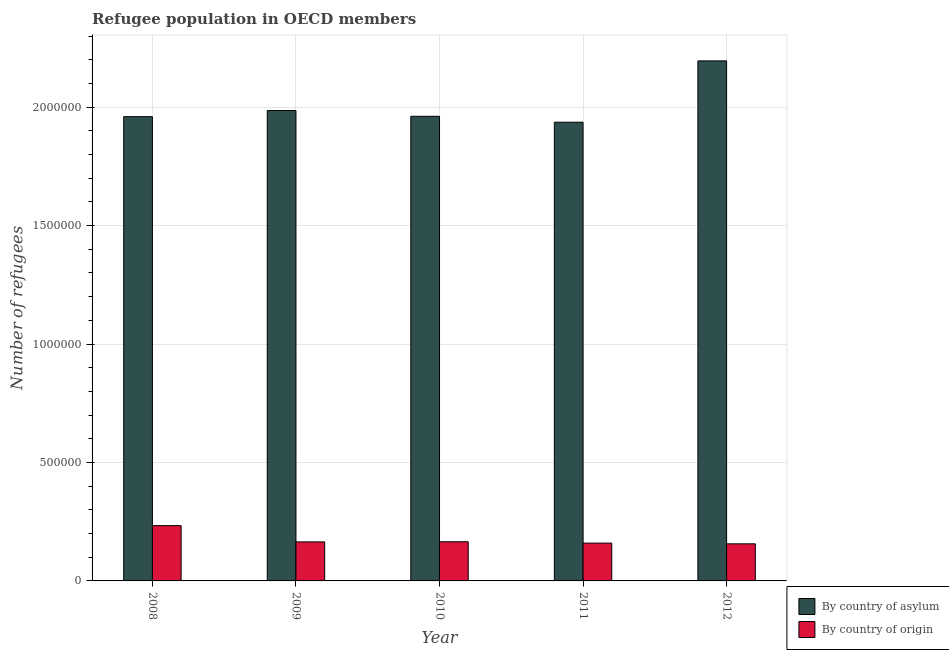Are the number of bars per tick equal to the number of legend labels?
Give a very brief answer. Yes. Are the number of bars on each tick of the X-axis equal?
Make the answer very short. Yes. In how many cases, is the number of bars for a given year not equal to the number of legend labels?
Provide a succinct answer. 0. What is the number of refugees by country of asylum in 2009?
Give a very brief answer. 1.99e+06. Across all years, what is the maximum number of refugees by country of asylum?
Provide a succinct answer. 2.20e+06. Across all years, what is the minimum number of refugees by country of origin?
Offer a very short reply. 1.57e+05. In which year was the number of refugees by country of origin maximum?
Provide a short and direct response. 2008. What is the total number of refugees by country of origin in the graph?
Your answer should be compact. 8.80e+05. What is the difference between the number of refugees by country of asylum in 2010 and that in 2012?
Your answer should be compact. -2.34e+05. What is the difference between the number of refugees by country of asylum in 2011 and the number of refugees by country of origin in 2008?
Give a very brief answer. -2.34e+04. What is the average number of refugees by country of asylum per year?
Your answer should be very brief. 2.01e+06. In how many years, is the number of refugees by country of origin greater than 800000?
Give a very brief answer. 0. What is the ratio of the number of refugees by country of asylum in 2011 to that in 2012?
Provide a succinct answer. 0.88. Is the number of refugees by country of asylum in 2008 less than that in 2009?
Ensure brevity in your answer.  Yes. What is the difference between the highest and the second highest number of refugees by country of asylum?
Your response must be concise. 2.10e+05. What is the difference between the highest and the lowest number of refugees by country of origin?
Give a very brief answer. 7.68e+04. Is the sum of the number of refugees by country of asylum in 2008 and 2009 greater than the maximum number of refugees by country of origin across all years?
Offer a terse response. Yes. What does the 1st bar from the left in 2011 represents?
Offer a very short reply. By country of asylum. What does the 2nd bar from the right in 2009 represents?
Provide a succinct answer. By country of asylum. How many bars are there?
Your response must be concise. 10. Are all the bars in the graph horizontal?
Your answer should be very brief. No. How many years are there in the graph?
Your response must be concise. 5. Are the values on the major ticks of Y-axis written in scientific E-notation?
Make the answer very short. No. Does the graph contain grids?
Provide a short and direct response. Yes. Where does the legend appear in the graph?
Provide a succinct answer. Bottom right. What is the title of the graph?
Provide a short and direct response. Refugee population in OECD members. Does "Non-resident workers" appear as one of the legend labels in the graph?
Keep it short and to the point. No. What is the label or title of the X-axis?
Your response must be concise. Year. What is the label or title of the Y-axis?
Your response must be concise. Number of refugees. What is the Number of refugees of By country of asylum in 2008?
Offer a terse response. 1.96e+06. What is the Number of refugees in By country of origin in 2008?
Keep it short and to the point. 2.33e+05. What is the Number of refugees in By country of asylum in 2009?
Provide a short and direct response. 1.99e+06. What is the Number of refugees in By country of origin in 2009?
Offer a very short reply. 1.65e+05. What is the Number of refugees of By country of asylum in 2010?
Keep it short and to the point. 1.96e+06. What is the Number of refugees of By country of origin in 2010?
Make the answer very short. 1.65e+05. What is the Number of refugees in By country of asylum in 2011?
Offer a very short reply. 1.94e+06. What is the Number of refugees of By country of origin in 2011?
Your answer should be compact. 1.60e+05. What is the Number of refugees of By country of asylum in 2012?
Make the answer very short. 2.20e+06. What is the Number of refugees of By country of origin in 2012?
Keep it short and to the point. 1.57e+05. Across all years, what is the maximum Number of refugees of By country of asylum?
Offer a terse response. 2.20e+06. Across all years, what is the maximum Number of refugees of By country of origin?
Your answer should be compact. 2.33e+05. Across all years, what is the minimum Number of refugees in By country of asylum?
Offer a terse response. 1.94e+06. Across all years, what is the minimum Number of refugees of By country of origin?
Give a very brief answer. 1.57e+05. What is the total Number of refugees in By country of asylum in the graph?
Make the answer very short. 1.00e+07. What is the total Number of refugees in By country of origin in the graph?
Offer a very short reply. 8.80e+05. What is the difference between the Number of refugees in By country of asylum in 2008 and that in 2009?
Give a very brief answer. -2.58e+04. What is the difference between the Number of refugees of By country of origin in 2008 and that in 2009?
Make the answer very short. 6.87e+04. What is the difference between the Number of refugees of By country of asylum in 2008 and that in 2010?
Your answer should be very brief. -1495. What is the difference between the Number of refugees in By country of origin in 2008 and that in 2010?
Make the answer very short. 6.82e+04. What is the difference between the Number of refugees in By country of asylum in 2008 and that in 2011?
Keep it short and to the point. 2.34e+04. What is the difference between the Number of refugees of By country of origin in 2008 and that in 2011?
Your answer should be very brief. 7.38e+04. What is the difference between the Number of refugees in By country of asylum in 2008 and that in 2012?
Your response must be concise. -2.35e+05. What is the difference between the Number of refugees in By country of origin in 2008 and that in 2012?
Give a very brief answer. 7.68e+04. What is the difference between the Number of refugees of By country of asylum in 2009 and that in 2010?
Provide a succinct answer. 2.43e+04. What is the difference between the Number of refugees of By country of origin in 2009 and that in 2010?
Give a very brief answer. -511. What is the difference between the Number of refugees in By country of asylum in 2009 and that in 2011?
Make the answer very short. 4.92e+04. What is the difference between the Number of refugees in By country of origin in 2009 and that in 2011?
Ensure brevity in your answer.  5135. What is the difference between the Number of refugees of By country of asylum in 2009 and that in 2012?
Keep it short and to the point. -2.10e+05. What is the difference between the Number of refugees of By country of origin in 2009 and that in 2012?
Ensure brevity in your answer.  8096. What is the difference between the Number of refugees in By country of asylum in 2010 and that in 2011?
Ensure brevity in your answer.  2.49e+04. What is the difference between the Number of refugees in By country of origin in 2010 and that in 2011?
Your answer should be compact. 5646. What is the difference between the Number of refugees in By country of asylum in 2010 and that in 2012?
Offer a very short reply. -2.34e+05. What is the difference between the Number of refugees of By country of origin in 2010 and that in 2012?
Your answer should be very brief. 8607. What is the difference between the Number of refugees in By country of asylum in 2011 and that in 2012?
Give a very brief answer. -2.59e+05. What is the difference between the Number of refugees of By country of origin in 2011 and that in 2012?
Your answer should be very brief. 2961. What is the difference between the Number of refugees of By country of asylum in 2008 and the Number of refugees of By country of origin in 2009?
Provide a succinct answer. 1.80e+06. What is the difference between the Number of refugees in By country of asylum in 2008 and the Number of refugees in By country of origin in 2010?
Offer a terse response. 1.79e+06. What is the difference between the Number of refugees in By country of asylum in 2008 and the Number of refugees in By country of origin in 2011?
Make the answer very short. 1.80e+06. What is the difference between the Number of refugees of By country of asylum in 2008 and the Number of refugees of By country of origin in 2012?
Ensure brevity in your answer.  1.80e+06. What is the difference between the Number of refugees of By country of asylum in 2009 and the Number of refugees of By country of origin in 2010?
Your response must be concise. 1.82e+06. What is the difference between the Number of refugees in By country of asylum in 2009 and the Number of refugees in By country of origin in 2011?
Keep it short and to the point. 1.83e+06. What is the difference between the Number of refugees in By country of asylum in 2009 and the Number of refugees in By country of origin in 2012?
Provide a short and direct response. 1.83e+06. What is the difference between the Number of refugees in By country of asylum in 2010 and the Number of refugees in By country of origin in 2011?
Your answer should be compact. 1.80e+06. What is the difference between the Number of refugees in By country of asylum in 2010 and the Number of refugees in By country of origin in 2012?
Keep it short and to the point. 1.80e+06. What is the difference between the Number of refugees of By country of asylum in 2011 and the Number of refugees of By country of origin in 2012?
Keep it short and to the point. 1.78e+06. What is the average Number of refugees in By country of asylum per year?
Keep it short and to the point. 2.01e+06. What is the average Number of refugees of By country of origin per year?
Provide a short and direct response. 1.76e+05. In the year 2008, what is the difference between the Number of refugees in By country of asylum and Number of refugees in By country of origin?
Give a very brief answer. 1.73e+06. In the year 2009, what is the difference between the Number of refugees in By country of asylum and Number of refugees in By country of origin?
Your answer should be very brief. 1.82e+06. In the year 2010, what is the difference between the Number of refugees of By country of asylum and Number of refugees of By country of origin?
Offer a terse response. 1.80e+06. In the year 2011, what is the difference between the Number of refugees of By country of asylum and Number of refugees of By country of origin?
Offer a terse response. 1.78e+06. In the year 2012, what is the difference between the Number of refugees in By country of asylum and Number of refugees in By country of origin?
Offer a very short reply. 2.04e+06. What is the ratio of the Number of refugees of By country of asylum in 2008 to that in 2009?
Your response must be concise. 0.99. What is the ratio of the Number of refugees of By country of origin in 2008 to that in 2009?
Keep it short and to the point. 1.42. What is the ratio of the Number of refugees of By country of asylum in 2008 to that in 2010?
Offer a terse response. 1. What is the ratio of the Number of refugees of By country of origin in 2008 to that in 2010?
Your response must be concise. 1.41. What is the ratio of the Number of refugees of By country of asylum in 2008 to that in 2011?
Make the answer very short. 1.01. What is the ratio of the Number of refugees of By country of origin in 2008 to that in 2011?
Offer a very short reply. 1.46. What is the ratio of the Number of refugees of By country of asylum in 2008 to that in 2012?
Offer a very short reply. 0.89. What is the ratio of the Number of refugees in By country of origin in 2008 to that in 2012?
Your answer should be very brief. 1.49. What is the ratio of the Number of refugees in By country of asylum in 2009 to that in 2010?
Offer a terse response. 1.01. What is the ratio of the Number of refugees in By country of asylum in 2009 to that in 2011?
Offer a very short reply. 1.03. What is the ratio of the Number of refugees of By country of origin in 2009 to that in 2011?
Give a very brief answer. 1.03. What is the ratio of the Number of refugees in By country of asylum in 2009 to that in 2012?
Your response must be concise. 0.9. What is the ratio of the Number of refugees of By country of origin in 2009 to that in 2012?
Keep it short and to the point. 1.05. What is the ratio of the Number of refugees of By country of asylum in 2010 to that in 2011?
Offer a terse response. 1.01. What is the ratio of the Number of refugees in By country of origin in 2010 to that in 2011?
Provide a short and direct response. 1.04. What is the ratio of the Number of refugees of By country of asylum in 2010 to that in 2012?
Your response must be concise. 0.89. What is the ratio of the Number of refugees in By country of origin in 2010 to that in 2012?
Your response must be concise. 1.05. What is the ratio of the Number of refugees in By country of asylum in 2011 to that in 2012?
Provide a short and direct response. 0.88. What is the ratio of the Number of refugees in By country of origin in 2011 to that in 2012?
Ensure brevity in your answer.  1.02. What is the difference between the highest and the second highest Number of refugees in By country of asylum?
Provide a succinct answer. 2.10e+05. What is the difference between the highest and the second highest Number of refugees of By country of origin?
Offer a terse response. 6.82e+04. What is the difference between the highest and the lowest Number of refugees in By country of asylum?
Ensure brevity in your answer.  2.59e+05. What is the difference between the highest and the lowest Number of refugees in By country of origin?
Keep it short and to the point. 7.68e+04. 